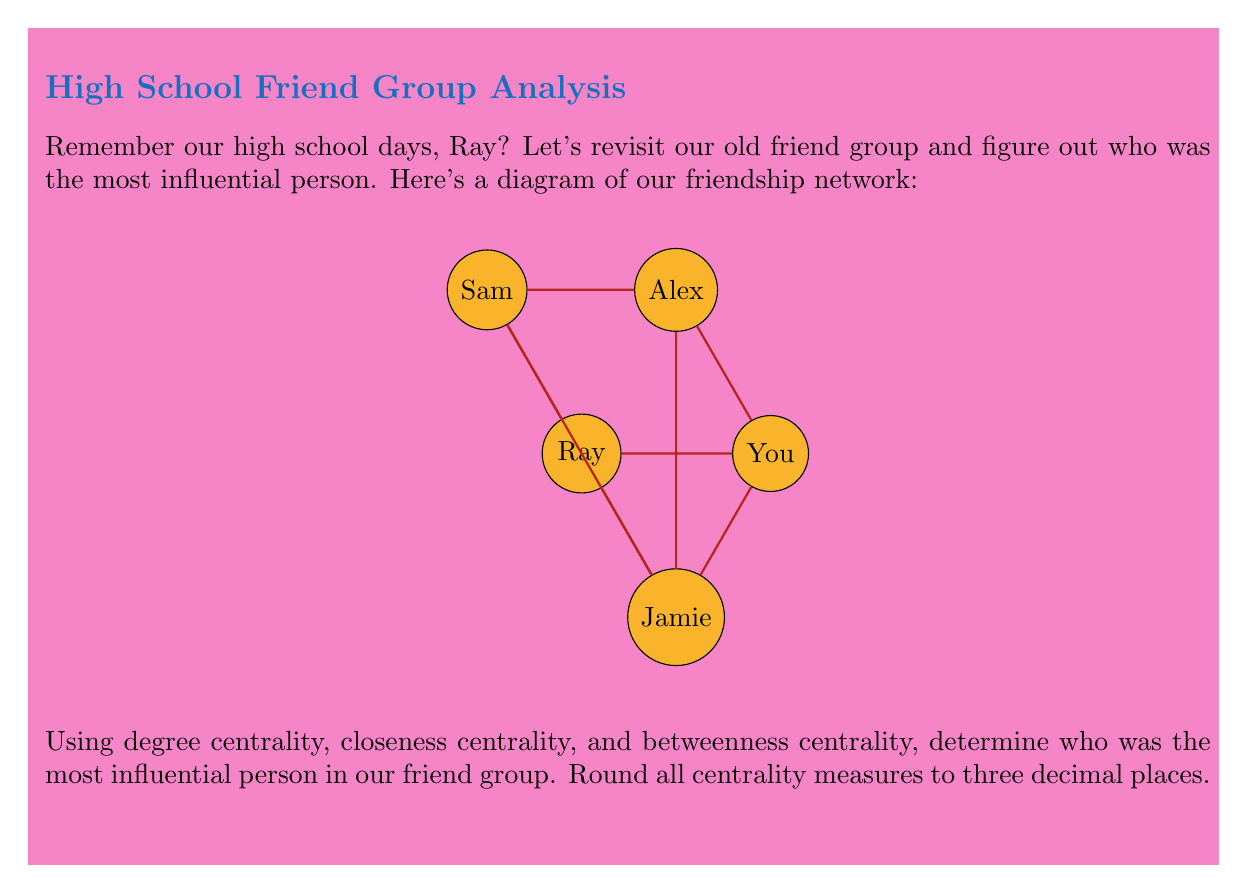Help me with this question. Let's calculate the three centrality measures for each person in the network:

1. Degree Centrality:
   - Ray: 3 connections
   - You: 3 connections
   - Alex: 4 connections
   - Sam: 3 connections
   - Jamie: 3 connections

   Normalized degree centrality: $C_D(v) = \frac{deg(v)}{n-1}$, where $n$ is the number of nodes.
   
   $C_D(\text{Ray}) = C_D(\text{You}) = C_D(\text{Sam}) = C_D(\text{Jamie}) = \frac{3}{4} = 0.750$
   $C_D(\text{Alex}) = \frac{4}{4} = 1.000$

2. Closeness Centrality:
   $C_C(v) = \frac{n-1}{\sum_{u \neq v} d(v,u)}$, where $d(v,u)$ is the shortest path between nodes $v$ and $u$.

   - Ray: $C_C(\text{Ray}) = \frac{4}{(1+1+2+1)} = 0.800$
   - You: $C_C(\text{You}) = \frac{4}{(1+1+2+1)} = 0.800$
   - Alex: $C_C(\text{Alex}) = \frac{4}{(1+1+1+1)} = 1.000$
   - Sam: $C_C(\text{Sam}) = \frac{4}{(2+2+1+1)} = 0.667$
   - Jamie: $C_C(\text{Jamie}) = \frac{4}{(1+1+1+2)} = 0.800$

3. Betweenness Centrality:
   $C_B(v) = \sum_{s \neq v \neq t} \frac{\sigma_{st}(v)}{\sigma_{st}}$, where $\sigma_{st}$ is the number of shortest paths from $s$ to $t$, and $\sigma_{st}(v)$ is the number of those paths passing through $v$.

   - Ray: $C_B(\text{Ray}) = 0$
   - You: $C_B(\text{You}) = 0$
   - Alex: $C_B(\text{Alex}) = 1$
   - Sam: $C_B(\text{Sam}) = 0$
   - Jamie: $C_B(\text{Jamie}) = 0$

   Normalized betweenness centrality: $C'_B(v) = \frac{2C_B(v)}{(n-1)(n-2)}$
   
   $C'_B(\text{Alex}) = \frac{2 \cdot 1}{(5-1)(5-2)} = 0.167$

Comparing all three measures, Alex has the highest scores in all centrality measures, making them the most influential person in the friend group.
Answer: Alex 